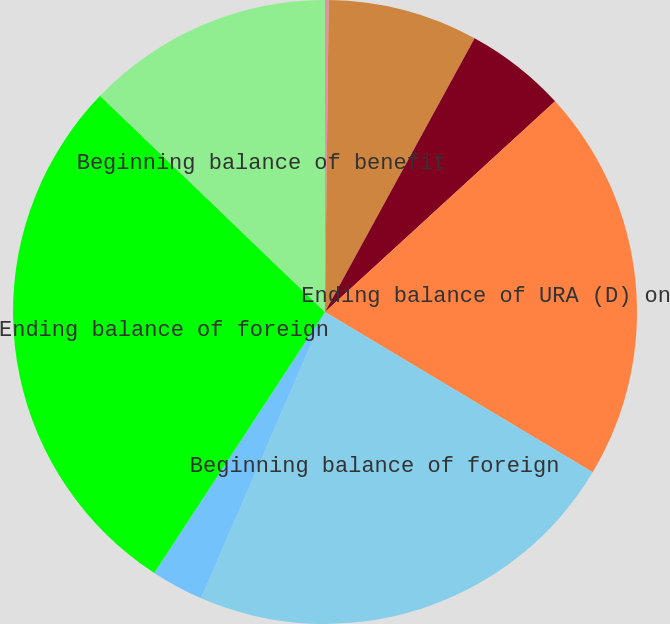<chart> <loc_0><loc_0><loc_500><loc_500><pie_chart><fcel>(Dollars in thousands)<fcel>Beginning balance of URA (D)<fcel>Current period change in URA<fcel>Ending balance of URA (D) on<fcel>Beginning balance of foreign<fcel>Current period change in<fcel>Ending balance of foreign<fcel>Beginning balance of benefit<nl><fcel>0.19%<fcel>7.77%<fcel>5.24%<fcel>20.39%<fcel>22.91%<fcel>2.72%<fcel>27.96%<fcel>12.82%<nl></chart> 